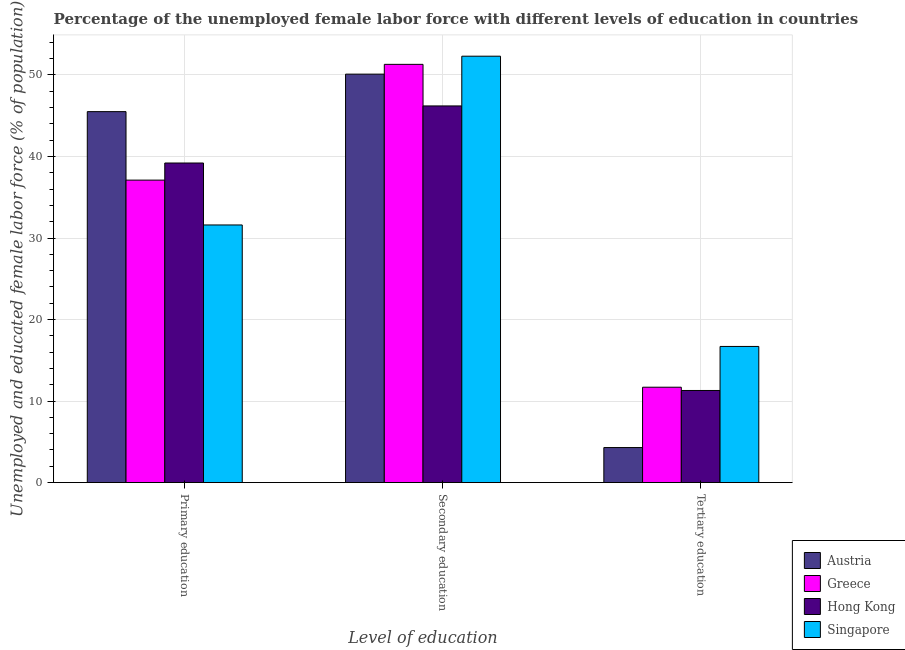How many groups of bars are there?
Your answer should be very brief. 3. Are the number of bars per tick equal to the number of legend labels?
Keep it short and to the point. Yes. Are the number of bars on each tick of the X-axis equal?
Provide a short and direct response. Yes. How many bars are there on the 3rd tick from the left?
Your answer should be very brief. 4. How many bars are there on the 1st tick from the right?
Ensure brevity in your answer.  4. What is the label of the 2nd group of bars from the left?
Provide a succinct answer. Secondary education. What is the percentage of female labor force who received primary education in Singapore?
Make the answer very short. 31.6. Across all countries, what is the maximum percentage of female labor force who received secondary education?
Give a very brief answer. 52.3. Across all countries, what is the minimum percentage of female labor force who received secondary education?
Make the answer very short. 46.2. In which country was the percentage of female labor force who received tertiary education maximum?
Provide a short and direct response. Singapore. What is the total percentage of female labor force who received secondary education in the graph?
Offer a terse response. 199.9. What is the difference between the percentage of female labor force who received secondary education in Hong Kong and that in Austria?
Make the answer very short. -3.9. What is the difference between the percentage of female labor force who received primary education in Singapore and the percentage of female labor force who received secondary education in Hong Kong?
Provide a succinct answer. -14.6. What is the average percentage of female labor force who received tertiary education per country?
Provide a short and direct response. 11. What is the difference between the percentage of female labor force who received primary education and percentage of female labor force who received secondary education in Austria?
Your answer should be compact. -4.6. What is the ratio of the percentage of female labor force who received tertiary education in Greece to that in Hong Kong?
Offer a terse response. 1.04. Is the percentage of female labor force who received secondary education in Austria less than that in Greece?
Your answer should be compact. Yes. What is the difference between the highest and the second highest percentage of female labor force who received tertiary education?
Provide a short and direct response. 5. What is the difference between the highest and the lowest percentage of female labor force who received tertiary education?
Your answer should be very brief. 12.4. In how many countries, is the percentage of female labor force who received tertiary education greater than the average percentage of female labor force who received tertiary education taken over all countries?
Your answer should be very brief. 3. Is the sum of the percentage of female labor force who received tertiary education in Greece and Austria greater than the maximum percentage of female labor force who received primary education across all countries?
Offer a very short reply. No. What does the 4th bar from the left in Tertiary education represents?
Your response must be concise. Singapore. What does the 1st bar from the right in Secondary education represents?
Make the answer very short. Singapore. Is it the case that in every country, the sum of the percentage of female labor force who received primary education and percentage of female labor force who received secondary education is greater than the percentage of female labor force who received tertiary education?
Give a very brief answer. Yes. Where does the legend appear in the graph?
Your answer should be very brief. Bottom right. How many legend labels are there?
Offer a very short reply. 4. What is the title of the graph?
Your answer should be very brief. Percentage of the unemployed female labor force with different levels of education in countries. What is the label or title of the X-axis?
Your answer should be very brief. Level of education. What is the label or title of the Y-axis?
Offer a very short reply. Unemployed and educated female labor force (% of population). What is the Unemployed and educated female labor force (% of population) of Austria in Primary education?
Make the answer very short. 45.5. What is the Unemployed and educated female labor force (% of population) of Greece in Primary education?
Give a very brief answer. 37.1. What is the Unemployed and educated female labor force (% of population) of Hong Kong in Primary education?
Offer a terse response. 39.2. What is the Unemployed and educated female labor force (% of population) of Singapore in Primary education?
Make the answer very short. 31.6. What is the Unemployed and educated female labor force (% of population) of Austria in Secondary education?
Offer a very short reply. 50.1. What is the Unemployed and educated female labor force (% of population) of Greece in Secondary education?
Provide a succinct answer. 51.3. What is the Unemployed and educated female labor force (% of population) in Hong Kong in Secondary education?
Your answer should be compact. 46.2. What is the Unemployed and educated female labor force (% of population) in Singapore in Secondary education?
Keep it short and to the point. 52.3. What is the Unemployed and educated female labor force (% of population) in Austria in Tertiary education?
Give a very brief answer. 4.3. What is the Unemployed and educated female labor force (% of population) in Greece in Tertiary education?
Give a very brief answer. 11.7. What is the Unemployed and educated female labor force (% of population) of Hong Kong in Tertiary education?
Your answer should be compact. 11.3. What is the Unemployed and educated female labor force (% of population) in Singapore in Tertiary education?
Your answer should be compact. 16.7. Across all Level of education, what is the maximum Unemployed and educated female labor force (% of population) of Austria?
Keep it short and to the point. 50.1. Across all Level of education, what is the maximum Unemployed and educated female labor force (% of population) in Greece?
Offer a terse response. 51.3. Across all Level of education, what is the maximum Unemployed and educated female labor force (% of population) in Hong Kong?
Offer a terse response. 46.2. Across all Level of education, what is the maximum Unemployed and educated female labor force (% of population) in Singapore?
Keep it short and to the point. 52.3. Across all Level of education, what is the minimum Unemployed and educated female labor force (% of population) in Austria?
Ensure brevity in your answer.  4.3. Across all Level of education, what is the minimum Unemployed and educated female labor force (% of population) of Greece?
Your response must be concise. 11.7. Across all Level of education, what is the minimum Unemployed and educated female labor force (% of population) of Hong Kong?
Your response must be concise. 11.3. Across all Level of education, what is the minimum Unemployed and educated female labor force (% of population) of Singapore?
Provide a short and direct response. 16.7. What is the total Unemployed and educated female labor force (% of population) in Austria in the graph?
Your answer should be very brief. 99.9. What is the total Unemployed and educated female labor force (% of population) of Greece in the graph?
Your answer should be compact. 100.1. What is the total Unemployed and educated female labor force (% of population) in Hong Kong in the graph?
Provide a succinct answer. 96.7. What is the total Unemployed and educated female labor force (% of population) of Singapore in the graph?
Your response must be concise. 100.6. What is the difference between the Unemployed and educated female labor force (% of population) in Greece in Primary education and that in Secondary education?
Keep it short and to the point. -14.2. What is the difference between the Unemployed and educated female labor force (% of population) of Singapore in Primary education and that in Secondary education?
Your answer should be very brief. -20.7. What is the difference between the Unemployed and educated female labor force (% of population) of Austria in Primary education and that in Tertiary education?
Offer a terse response. 41.2. What is the difference between the Unemployed and educated female labor force (% of population) of Greece in Primary education and that in Tertiary education?
Your answer should be compact. 25.4. What is the difference between the Unemployed and educated female labor force (% of population) in Hong Kong in Primary education and that in Tertiary education?
Ensure brevity in your answer.  27.9. What is the difference between the Unemployed and educated female labor force (% of population) in Singapore in Primary education and that in Tertiary education?
Offer a terse response. 14.9. What is the difference between the Unemployed and educated female labor force (% of population) in Austria in Secondary education and that in Tertiary education?
Keep it short and to the point. 45.8. What is the difference between the Unemployed and educated female labor force (% of population) in Greece in Secondary education and that in Tertiary education?
Give a very brief answer. 39.6. What is the difference between the Unemployed and educated female labor force (% of population) of Hong Kong in Secondary education and that in Tertiary education?
Give a very brief answer. 34.9. What is the difference between the Unemployed and educated female labor force (% of population) of Singapore in Secondary education and that in Tertiary education?
Ensure brevity in your answer.  35.6. What is the difference between the Unemployed and educated female labor force (% of population) of Austria in Primary education and the Unemployed and educated female labor force (% of population) of Singapore in Secondary education?
Your answer should be very brief. -6.8. What is the difference between the Unemployed and educated female labor force (% of population) of Greece in Primary education and the Unemployed and educated female labor force (% of population) of Singapore in Secondary education?
Your answer should be very brief. -15.2. What is the difference between the Unemployed and educated female labor force (% of population) in Hong Kong in Primary education and the Unemployed and educated female labor force (% of population) in Singapore in Secondary education?
Offer a terse response. -13.1. What is the difference between the Unemployed and educated female labor force (% of population) of Austria in Primary education and the Unemployed and educated female labor force (% of population) of Greece in Tertiary education?
Offer a terse response. 33.8. What is the difference between the Unemployed and educated female labor force (% of population) of Austria in Primary education and the Unemployed and educated female labor force (% of population) of Hong Kong in Tertiary education?
Make the answer very short. 34.2. What is the difference between the Unemployed and educated female labor force (% of population) in Austria in Primary education and the Unemployed and educated female labor force (% of population) in Singapore in Tertiary education?
Keep it short and to the point. 28.8. What is the difference between the Unemployed and educated female labor force (% of population) in Greece in Primary education and the Unemployed and educated female labor force (% of population) in Hong Kong in Tertiary education?
Make the answer very short. 25.8. What is the difference between the Unemployed and educated female labor force (% of population) of Greece in Primary education and the Unemployed and educated female labor force (% of population) of Singapore in Tertiary education?
Ensure brevity in your answer.  20.4. What is the difference between the Unemployed and educated female labor force (% of population) in Austria in Secondary education and the Unemployed and educated female labor force (% of population) in Greece in Tertiary education?
Make the answer very short. 38.4. What is the difference between the Unemployed and educated female labor force (% of population) in Austria in Secondary education and the Unemployed and educated female labor force (% of population) in Hong Kong in Tertiary education?
Ensure brevity in your answer.  38.8. What is the difference between the Unemployed and educated female labor force (% of population) in Austria in Secondary education and the Unemployed and educated female labor force (% of population) in Singapore in Tertiary education?
Your answer should be compact. 33.4. What is the difference between the Unemployed and educated female labor force (% of population) in Greece in Secondary education and the Unemployed and educated female labor force (% of population) in Hong Kong in Tertiary education?
Your answer should be very brief. 40. What is the difference between the Unemployed and educated female labor force (% of population) in Greece in Secondary education and the Unemployed and educated female labor force (% of population) in Singapore in Tertiary education?
Your answer should be compact. 34.6. What is the difference between the Unemployed and educated female labor force (% of population) of Hong Kong in Secondary education and the Unemployed and educated female labor force (% of population) of Singapore in Tertiary education?
Provide a short and direct response. 29.5. What is the average Unemployed and educated female labor force (% of population) of Austria per Level of education?
Your answer should be very brief. 33.3. What is the average Unemployed and educated female labor force (% of population) of Greece per Level of education?
Provide a short and direct response. 33.37. What is the average Unemployed and educated female labor force (% of population) in Hong Kong per Level of education?
Provide a succinct answer. 32.23. What is the average Unemployed and educated female labor force (% of population) of Singapore per Level of education?
Make the answer very short. 33.53. What is the difference between the Unemployed and educated female labor force (% of population) in Austria and Unemployed and educated female labor force (% of population) in Greece in Primary education?
Your answer should be compact. 8.4. What is the difference between the Unemployed and educated female labor force (% of population) in Austria and Unemployed and educated female labor force (% of population) in Hong Kong in Primary education?
Provide a succinct answer. 6.3. What is the difference between the Unemployed and educated female labor force (% of population) of Austria and Unemployed and educated female labor force (% of population) of Singapore in Primary education?
Your answer should be very brief. 13.9. What is the difference between the Unemployed and educated female labor force (% of population) of Greece and Unemployed and educated female labor force (% of population) of Hong Kong in Primary education?
Your answer should be very brief. -2.1. What is the difference between the Unemployed and educated female labor force (% of population) of Austria and Unemployed and educated female labor force (% of population) of Greece in Secondary education?
Your answer should be compact. -1.2. What is the difference between the Unemployed and educated female labor force (% of population) of Greece and Unemployed and educated female labor force (% of population) of Hong Kong in Secondary education?
Give a very brief answer. 5.1. What is the difference between the Unemployed and educated female labor force (% of population) of Hong Kong and Unemployed and educated female labor force (% of population) of Singapore in Secondary education?
Ensure brevity in your answer.  -6.1. What is the difference between the Unemployed and educated female labor force (% of population) in Austria and Unemployed and educated female labor force (% of population) in Greece in Tertiary education?
Offer a terse response. -7.4. What is the difference between the Unemployed and educated female labor force (% of population) in Greece and Unemployed and educated female labor force (% of population) in Hong Kong in Tertiary education?
Give a very brief answer. 0.4. What is the difference between the Unemployed and educated female labor force (% of population) of Greece and Unemployed and educated female labor force (% of population) of Singapore in Tertiary education?
Your response must be concise. -5. What is the ratio of the Unemployed and educated female labor force (% of population) of Austria in Primary education to that in Secondary education?
Give a very brief answer. 0.91. What is the ratio of the Unemployed and educated female labor force (% of population) of Greece in Primary education to that in Secondary education?
Keep it short and to the point. 0.72. What is the ratio of the Unemployed and educated female labor force (% of population) in Hong Kong in Primary education to that in Secondary education?
Your response must be concise. 0.85. What is the ratio of the Unemployed and educated female labor force (% of population) of Singapore in Primary education to that in Secondary education?
Your answer should be very brief. 0.6. What is the ratio of the Unemployed and educated female labor force (% of population) in Austria in Primary education to that in Tertiary education?
Your answer should be compact. 10.58. What is the ratio of the Unemployed and educated female labor force (% of population) of Greece in Primary education to that in Tertiary education?
Make the answer very short. 3.17. What is the ratio of the Unemployed and educated female labor force (% of population) in Hong Kong in Primary education to that in Tertiary education?
Your answer should be compact. 3.47. What is the ratio of the Unemployed and educated female labor force (% of population) of Singapore in Primary education to that in Tertiary education?
Offer a terse response. 1.89. What is the ratio of the Unemployed and educated female labor force (% of population) in Austria in Secondary education to that in Tertiary education?
Your response must be concise. 11.65. What is the ratio of the Unemployed and educated female labor force (% of population) of Greece in Secondary education to that in Tertiary education?
Provide a succinct answer. 4.38. What is the ratio of the Unemployed and educated female labor force (% of population) in Hong Kong in Secondary education to that in Tertiary education?
Your answer should be very brief. 4.09. What is the ratio of the Unemployed and educated female labor force (% of population) in Singapore in Secondary education to that in Tertiary education?
Provide a succinct answer. 3.13. What is the difference between the highest and the second highest Unemployed and educated female labor force (% of population) of Greece?
Provide a short and direct response. 14.2. What is the difference between the highest and the second highest Unemployed and educated female labor force (% of population) in Singapore?
Offer a terse response. 20.7. What is the difference between the highest and the lowest Unemployed and educated female labor force (% of population) of Austria?
Offer a terse response. 45.8. What is the difference between the highest and the lowest Unemployed and educated female labor force (% of population) in Greece?
Provide a short and direct response. 39.6. What is the difference between the highest and the lowest Unemployed and educated female labor force (% of population) in Hong Kong?
Ensure brevity in your answer.  34.9. What is the difference between the highest and the lowest Unemployed and educated female labor force (% of population) in Singapore?
Your answer should be compact. 35.6. 